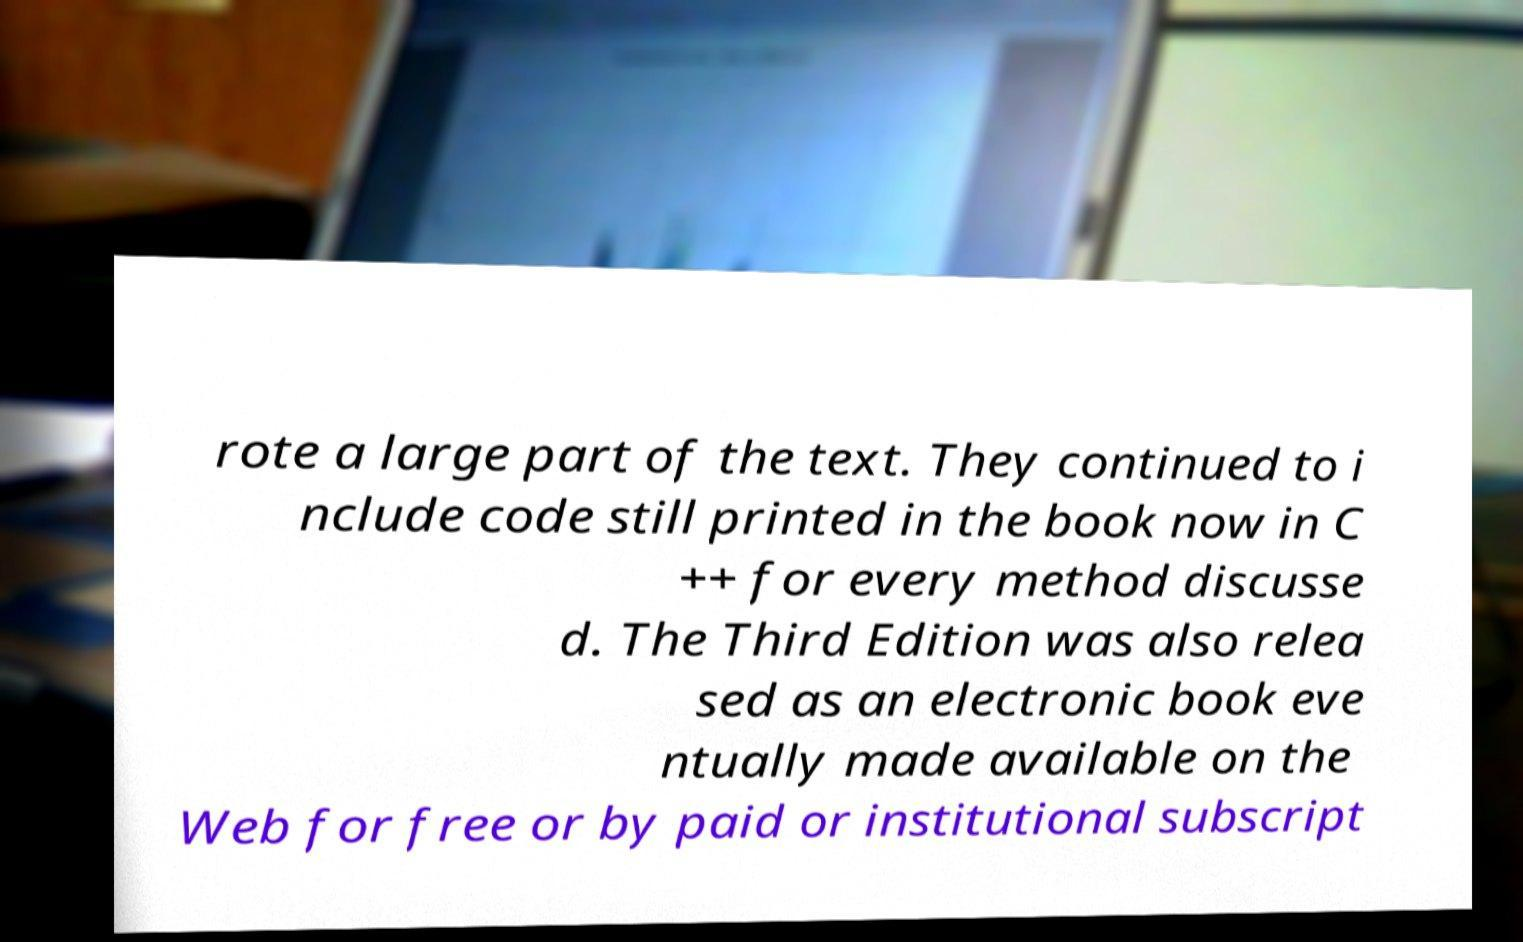Can you accurately transcribe the text from the provided image for me? rote a large part of the text. They continued to i nclude code still printed in the book now in C ++ for every method discusse d. The Third Edition was also relea sed as an electronic book eve ntually made available on the Web for free or by paid or institutional subscript 